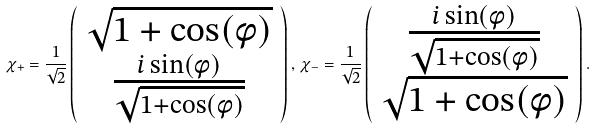Convert formula to latex. <formula><loc_0><loc_0><loc_500><loc_500>\chi _ { + } = \frac { 1 } { \sqrt { 2 } } \left ( \begin{array} { c } \sqrt { 1 + \cos ( \phi ) } \\ \frac { i \sin ( \phi ) } { \sqrt { 1 + \cos ( \phi ) } } \end{array} \right ) , \, \chi _ { - } = \frac { 1 } { \sqrt { 2 } } \left ( \begin{array} { c } \frac { i \sin ( \phi ) } { \sqrt { 1 + \cos ( \phi ) } } \\ \sqrt { 1 + \cos ( \phi ) } \\ \end{array} \right ) .</formula> 